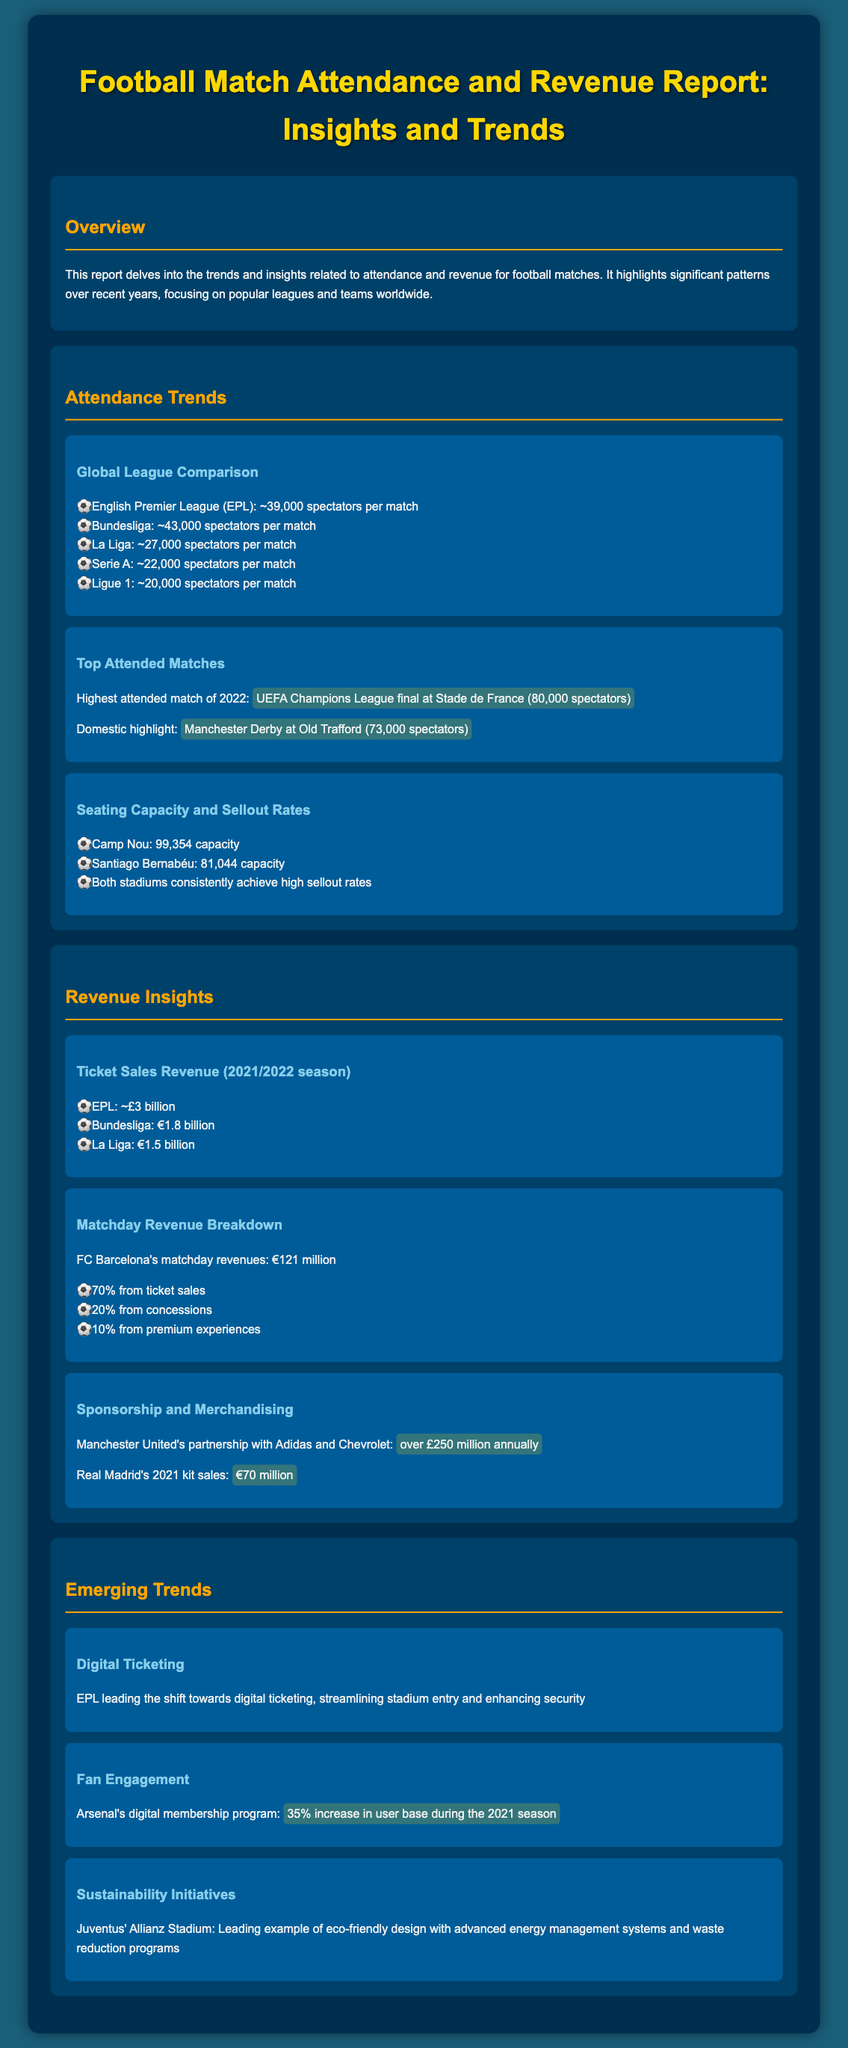What is the average attendance in the English Premier League? The section lists the average attendance for various leagues, showing that the EPL has ~39,000 spectators per match.
Answer: ~39,000 spectators per match Which stadium has the highest seating capacity? The document highlights the seating capacities of major stadiums, indicating Camp Nou has a capacity of 99,354.
Answer: 99,354 capacity What is the matchday revenue for FC Barcelona? The revenue insights detail FC Barcelona's matchday revenues, stating they generate €121 million.
Answer: €121 million What percentage of FC Barcelona's matchday revenue comes from ticket sales? The report breaks down FC Barcelona's revenue sources, noting that 70% comes from ticket sales.
Answer: 70% What was the highest attended match in 2022? The document mentions the UEFA Champions League final at Stade de France as the highest attended match of 2022 with 80,000 spectators.
Answer: UEFA Champions League final at Stade de France (80,000 spectators) How much annual revenue does Manchester United earn from sponsorships? The document cites Manchester United's partnerships, specifically noting they earn over £250 million annually.
Answer: over £250 million annually What increase did Arsenal see in their digital membership program during the 2021 season? The section about fan engagement indicates Arsenal experienced a 35% increase in user base during that season.
Answer: 35% Which league is leading the shift towards digital ticketing? The trends section states that the EPL is leading the shift towards digital ticketing.
Answer: EPL What initiative is highlighted at Juventus' Allianz Stadium? The report mentions Juventus is known for its eco-friendly design and advanced energy management systems.
Answer: eco-friendly design 